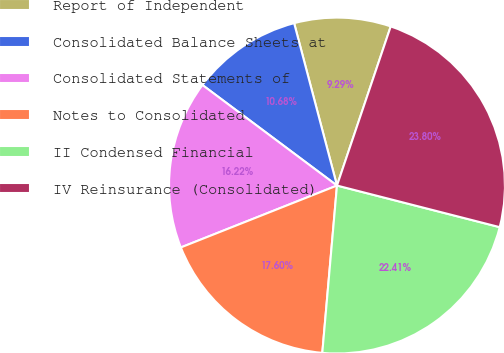Convert chart. <chart><loc_0><loc_0><loc_500><loc_500><pie_chart><fcel>Report of Independent<fcel>Consolidated Balance Sheets at<fcel>Consolidated Statements of<fcel>Notes to Consolidated<fcel>II Condensed Financial<fcel>IV Reinsurance (Consolidated)<nl><fcel>9.29%<fcel>10.68%<fcel>16.22%<fcel>17.6%<fcel>22.41%<fcel>23.8%<nl></chart> 